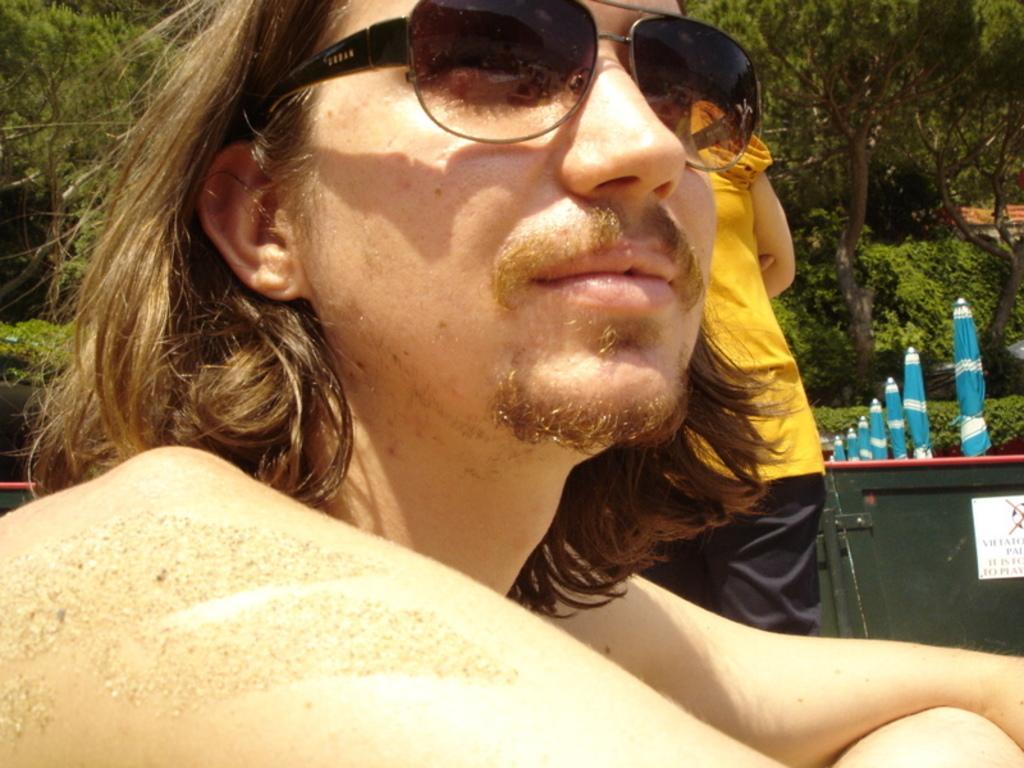Please provide a concise description of this image. In the foreground of the picture we can see a person wearing spectacles. In the middle we can see plants, blue color objects, women and other things. In the background there are trees and we can see roof also. 